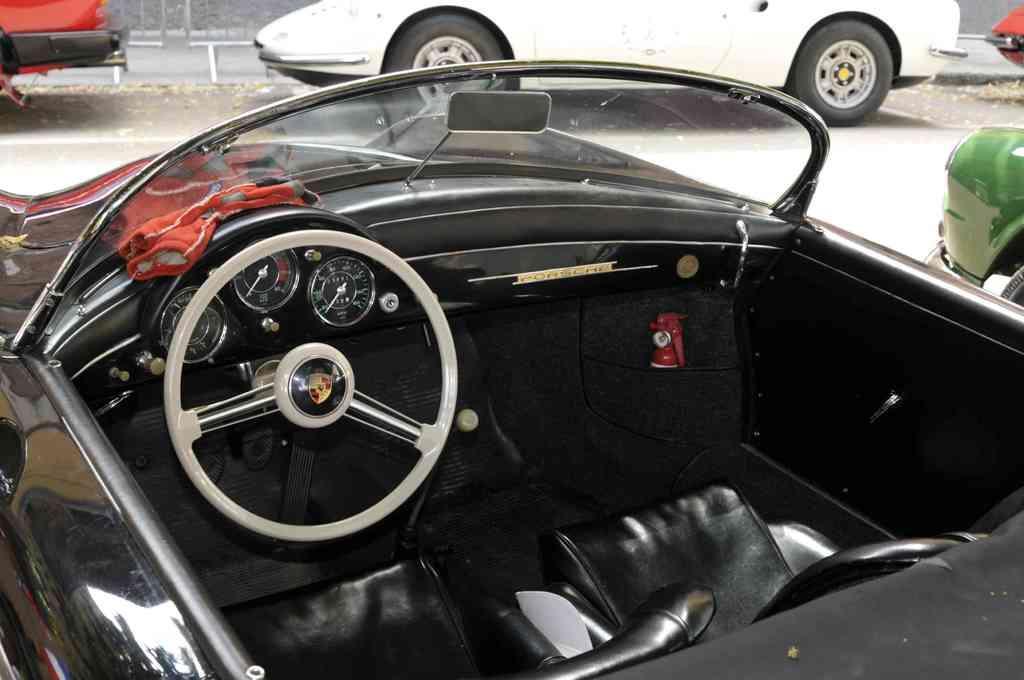Describe this image in one or two sentences. In this image there is a black color car. In the background of the image there are cars on the road. 